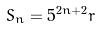Convert formula to latex. <formula><loc_0><loc_0><loc_500><loc_500>S _ { n } = 5 ^ { 2 n + 2 } r</formula> 